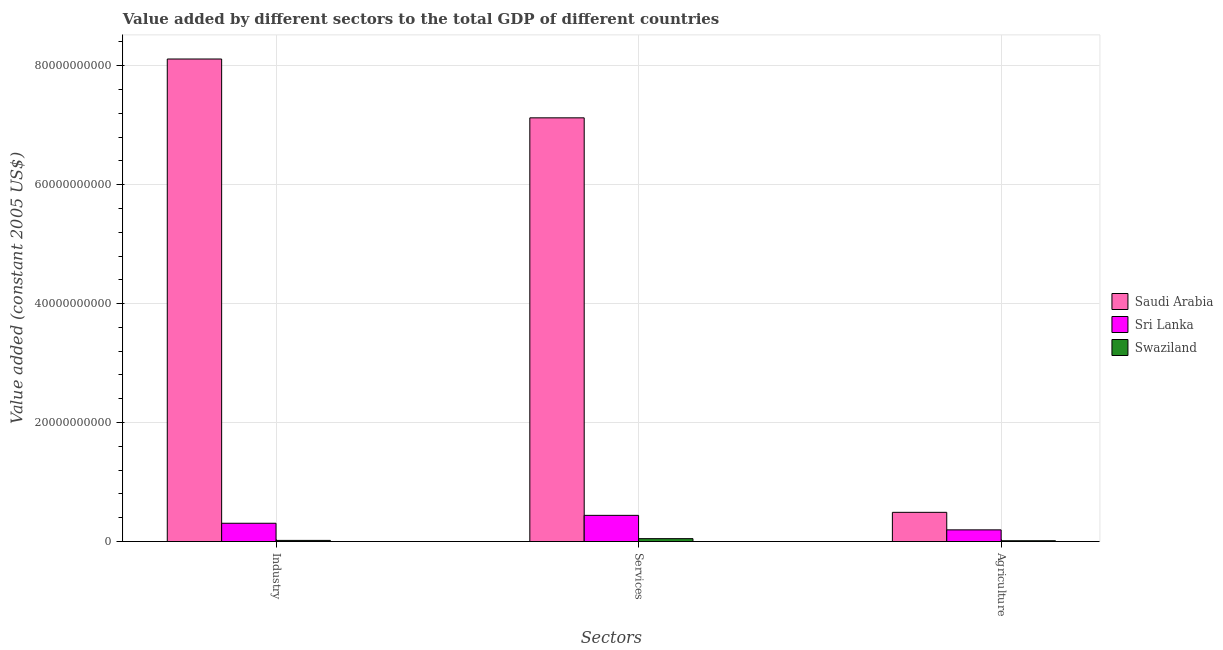How many different coloured bars are there?
Give a very brief answer. 3. How many groups of bars are there?
Your answer should be very brief. 3. How many bars are there on the 1st tick from the left?
Your answer should be very brief. 3. What is the label of the 3rd group of bars from the left?
Keep it short and to the point. Agriculture. What is the value added by industrial sector in Saudi Arabia?
Provide a short and direct response. 8.11e+1. Across all countries, what is the maximum value added by industrial sector?
Keep it short and to the point. 8.11e+1. Across all countries, what is the minimum value added by agricultural sector?
Provide a short and direct response. 1.38e+08. In which country was the value added by industrial sector maximum?
Your response must be concise. Saudi Arabia. In which country was the value added by agricultural sector minimum?
Provide a succinct answer. Swaziland. What is the total value added by services in the graph?
Give a very brief answer. 7.61e+1. What is the difference between the value added by services in Sri Lanka and that in Swaziland?
Your response must be concise. 3.92e+09. What is the difference between the value added by industrial sector in Saudi Arabia and the value added by services in Swaziland?
Offer a very short reply. 8.06e+1. What is the average value added by industrial sector per country?
Offer a terse response. 2.81e+1. What is the difference between the value added by industrial sector and value added by agricultural sector in Swaziland?
Ensure brevity in your answer.  5.63e+07. What is the ratio of the value added by industrial sector in Swaziland to that in Sri Lanka?
Provide a short and direct response. 0.06. Is the value added by agricultural sector in Swaziland less than that in Sri Lanka?
Give a very brief answer. Yes. Is the difference between the value added by services in Saudi Arabia and Sri Lanka greater than the difference between the value added by industrial sector in Saudi Arabia and Sri Lanka?
Offer a very short reply. No. What is the difference between the highest and the second highest value added by industrial sector?
Provide a succinct answer. 7.80e+1. What is the difference between the highest and the lowest value added by industrial sector?
Your answer should be very brief. 8.09e+1. In how many countries, is the value added by agricultural sector greater than the average value added by agricultural sector taken over all countries?
Provide a succinct answer. 1. What does the 2nd bar from the left in Industry represents?
Offer a terse response. Sri Lanka. What does the 2nd bar from the right in Services represents?
Ensure brevity in your answer.  Sri Lanka. How many bars are there?
Provide a succinct answer. 9. Are all the bars in the graph horizontal?
Make the answer very short. No. What is the difference between two consecutive major ticks on the Y-axis?
Your answer should be compact. 2.00e+1. Are the values on the major ticks of Y-axis written in scientific E-notation?
Provide a short and direct response. No. Does the graph contain any zero values?
Make the answer very short. No. How many legend labels are there?
Offer a very short reply. 3. What is the title of the graph?
Offer a terse response. Value added by different sectors to the total GDP of different countries. What is the label or title of the X-axis?
Provide a succinct answer. Sectors. What is the label or title of the Y-axis?
Offer a terse response. Value added (constant 2005 US$). What is the Value added (constant 2005 US$) in Saudi Arabia in Industry?
Make the answer very short. 8.11e+1. What is the Value added (constant 2005 US$) in Sri Lanka in Industry?
Your answer should be very brief. 3.08e+09. What is the Value added (constant 2005 US$) of Swaziland in Industry?
Keep it short and to the point. 1.95e+08. What is the Value added (constant 2005 US$) in Saudi Arabia in Services?
Provide a succinct answer. 7.12e+1. What is the Value added (constant 2005 US$) of Sri Lanka in Services?
Provide a succinct answer. 4.41e+09. What is the Value added (constant 2005 US$) of Swaziland in Services?
Give a very brief answer. 4.89e+08. What is the Value added (constant 2005 US$) in Saudi Arabia in Agriculture?
Offer a terse response. 4.91e+09. What is the Value added (constant 2005 US$) of Sri Lanka in Agriculture?
Provide a succinct answer. 1.97e+09. What is the Value added (constant 2005 US$) of Swaziland in Agriculture?
Your answer should be compact. 1.38e+08. Across all Sectors, what is the maximum Value added (constant 2005 US$) of Saudi Arabia?
Keep it short and to the point. 8.11e+1. Across all Sectors, what is the maximum Value added (constant 2005 US$) of Sri Lanka?
Give a very brief answer. 4.41e+09. Across all Sectors, what is the maximum Value added (constant 2005 US$) of Swaziland?
Your answer should be compact. 4.89e+08. Across all Sectors, what is the minimum Value added (constant 2005 US$) of Saudi Arabia?
Your answer should be compact. 4.91e+09. Across all Sectors, what is the minimum Value added (constant 2005 US$) in Sri Lanka?
Keep it short and to the point. 1.97e+09. Across all Sectors, what is the minimum Value added (constant 2005 US$) in Swaziland?
Ensure brevity in your answer.  1.38e+08. What is the total Value added (constant 2005 US$) in Saudi Arabia in the graph?
Give a very brief answer. 1.57e+11. What is the total Value added (constant 2005 US$) in Sri Lanka in the graph?
Provide a succinct answer. 9.45e+09. What is the total Value added (constant 2005 US$) in Swaziland in the graph?
Your answer should be very brief. 8.22e+08. What is the difference between the Value added (constant 2005 US$) in Saudi Arabia in Industry and that in Services?
Keep it short and to the point. 9.89e+09. What is the difference between the Value added (constant 2005 US$) of Sri Lanka in Industry and that in Services?
Give a very brief answer. -1.33e+09. What is the difference between the Value added (constant 2005 US$) of Swaziland in Industry and that in Services?
Offer a very short reply. -2.95e+08. What is the difference between the Value added (constant 2005 US$) in Saudi Arabia in Industry and that in Agriculture?
Provide a short and direct response. 7.62e+1. What is the difference between the Value added (constant 2005 US$) of Sri Lanka in Industry and that in Agriculture?
Ensure brevity in your answer.  1.11e+09. What is the difference between the Value added (constant 2005 US$) of Swaziland in Industry and that in Agriculture?
Your answer should be compact. 5.63e+07. What is the difference between the Value added (constant 2005 US$) of Saudi Arabia in Services and that in Agriculture?
Give a very brief answer. 6.63e+1. What is the difference between the Value added (constant 2005 US$) of Sri Lanka in Services and that in Agriculture?
Your answer should be very brief. 2.44e+09. What is the difference between the Value added (constant 2005 US$) in Swaziland in Services and that in Agriculture?
Your answer should be very brief. 3.51e+08. What is the difference between the Value added (constant 2005 US$) of Saudi Arabia in Industry and the Value added (constant 2005 US$) of Sri Lanka in Services?
Keep it short and to the point. 7.67e+1. What is the difference between the Value added (constant 2005 US$) in Saudi Arabia in Industry and the Value added (constant 2005 US$) in Swaziland in Services?
Provide a short and direct response. 8.06e+1. What is the difference between the Value added (constant 2005 US$) of Sri Lanka in Industry and the Value added (constant 2005 US$) of Swaziland in Services?
Your response must be concise. 2.59e+09. What is the difference between the Value added (constant 2005 US$) of Saudi Arabia in Industry and the Value added (constant 2005 US$) of Sri Lanka in Agriculture?
Offer a terse response. 7.91e+1. What is the difference between the Value added (constant 2005 US$) in Saudi Arabia in Industry and the Value added (constant 2005 US$) in Swaziland in Agriculture?
Your answer should be very brief. 8.10e+1. What is the difference between the Value added (constant 2005 US$) of Sri Lanka in Industry and the Value added (constant 2005 US$) of Swaziland in Agriculture?
Keep it short and to the point. 2.94e+09. What is the difference between the Value added (constant 2005 US$) of Saudi Arabia in Services and the Value added (constant 2005 US$) of Sri Lanka in Agriculture?
Provide a short and direct response. 6.93e+1. What is the difference between the Value added (constant 2005 US$) of Saudi Arabia in Services and the Value added (constant 2005 US$) of Swaziland in Agriculture?
Offer a terse response. 7.11e+1. What is the difference between the Value added (constant 2005 US$) of Sri Lanka in Services and the Value added (constant 2005 US$) of Swaziland in Agriculture?
Your answer should be very brief. 4.27e+09. What is the average Value added (constant 2005 US$) in Saudi Arabia per Sectors?
Provide a short and direct response. 5.24e+1. What is the average Value added (constant 2005 US$) of Sri Lanka per Sectors?
Provide a succinct answer. 3.15e+09. What is the average Value added (constant 2005 US$) in Swaziland per Sectors?
Ensure brevity in your answer.  2.74e+08. What is the difference between the Value added (constant 2005 US$) in Saudi Arabia and Value added (constant 2005 US$) in Sri Lanka in Industry?
Offer a very short reply. 7.80e+1. What is the difference between the Value added (constant 2005 US$) of Saudi Arabia and Value added (constant 2005 US$) of Swaziland in Industry?
Give a very brief answer. 8.09e+1. What is the difference between the Value added (constant 2005 US$) of Sri Lanka and Value added (constant 2005 US$) of Swaziland in Industry?
Make the answer very short. 2.88e+09. What is the difference between the Value added (constant 2005 US$) in Saudi Arabia and Value added (constant 2005 US$) in Sri Lanka in Services?
Ensure brevity in your answer.  6.68e+1. What is the difference between the Value added (constant 2005 US$) in Saudi Arabia and Value added (constant 2005 US$) in Swaziland in Services?
Offer a very short reply. 7.07e+1. What is the difference between the Value added (constant 2005 US$) of Sri Lanka and Value added (constant 2005 US$) of Swaziland in Services?
Your answer should be compact. 3.92e+09. What is the difference between the Value added (constant 2005 US$) in Saudi Arabia and Value added (constant 2005 US$) in Sri Lanka in Agriculture?
Offer a terse response. 2.95e+09. What is the difference between the Value added (constant 2005 US$) of Saudi Arabia and Value added (constant 2005 US$) of Swaziland in Agriculture?
Offer a terse response. 4.77e+09. What is the difference between the Value added (constant 2005 US$) in Sri Lanka and Value added (constant 2005 US$) in Swaziland in Agriculture?
Provide a short and direct response. 1.83e+09. What is the ratio of the Value added (constant 2005 US$) in Saudi Arabia in Industry to that in Services?
Your response must be concise. 1.14. What is the ratio of the Value added (constant 2005 US$) of Sri Lanka in Industry to that in Services?
Your answer should be very brief. 0.7. What is the ratio of the Value added (constant 2005 US$) in Swaziland in Industry to that in Services?
Provide a short and direct response. 0.4. What is the ratio of the Value added (constant 2005 US$) of Saudi Arabia in Industry to that in Agriculture?
Offer a very short reply. 16.51. What is the ratio of the Value added (constant 2005 US$) in Sri Lanka in Industry to that in Agriculture?
Offer a terse response. 1.56. What is the ratio of the Value added (constant 2005 US$) in Swaziland in Industry to that in Agriculture?
Your answer should be very brief. 1.41. What is the ratio of the Value added (constant 2005 US$) of Saudi Arabia in Services to that in Agriculture?
Offer a very short reply. 14.5. What is the ratio of the Value added (constant 2005 US$) in Sri Lanka in Services to that in Agriculture?
Make the answer very short. 2.24. What is the ratio of the Value added (constant 2005 US$) of Swaziland in Services to that in Agriculture?
Offer a very short reply. 3.54. What is the difference between the highest and the second highest Value added (constant 2005 US$) in Saudi Arabia?
Provide a short and direct response. 9.89e+09. What is the difference between the highest and the second highest Value added (constant 2005 US$) of Sri Lanka?
Provide a short and direct response. 1.33e+09. What is the difference between the highest and the second highest Value added (constant 2005 US$) in Swaziland?
Offer a terse response. 2.95e+08. What is the difference between the highest and the lowest Value added (constant 2005 US$) in Saudi Arabia?
Offer a terse response. 7.62e+1. What is the difference between the highest and the lowest Value added (constant 2005 US$) of Sri Lanka?
Keep it short and to the point. 2.44e+09. What is the difference between the highest and the lowest Value added (constant 2005 US$) in Swaziland?
Provide a succinct answer. 3.51e+08. 